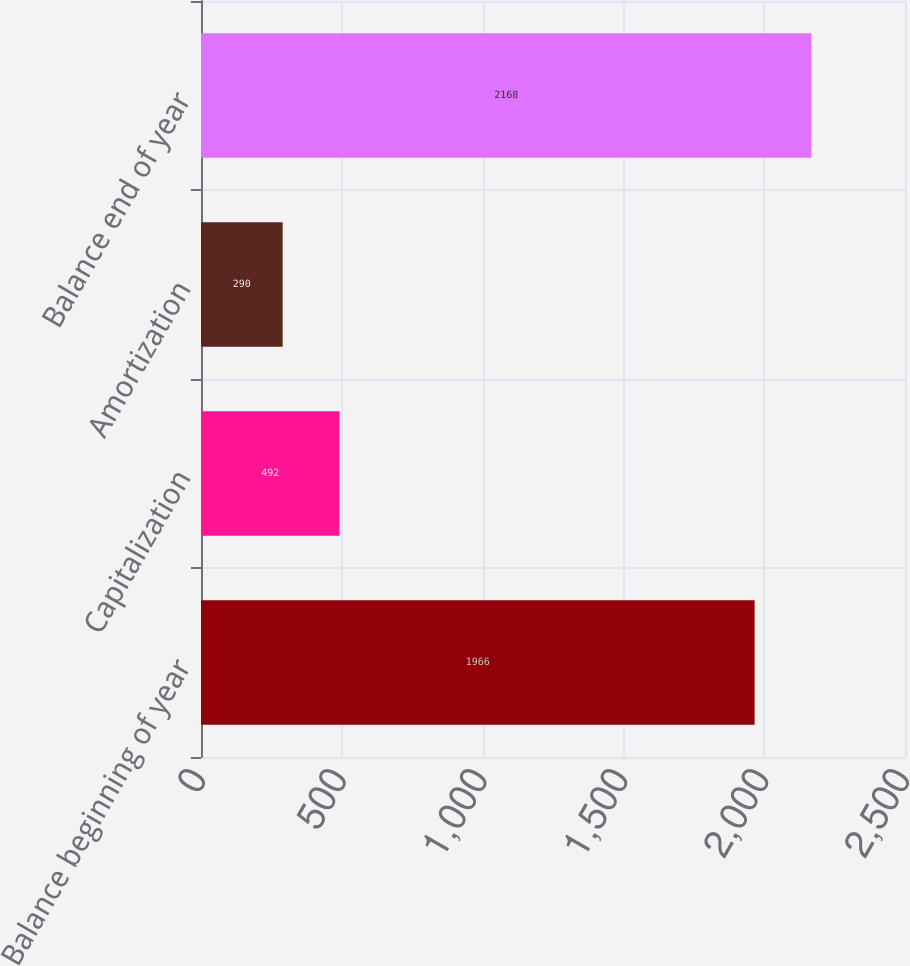Convert chart to OTSL. <chart><loc_0><loc_0><loc_500><loc_500><bar_chart><fcel>Balance beginning of year<fcel>Capitalization<fcel>Amortization<fcel>Balance end of year<nl><fcel>1966<fcel>492<fcel>290<fcel>2168<nl></chart> 